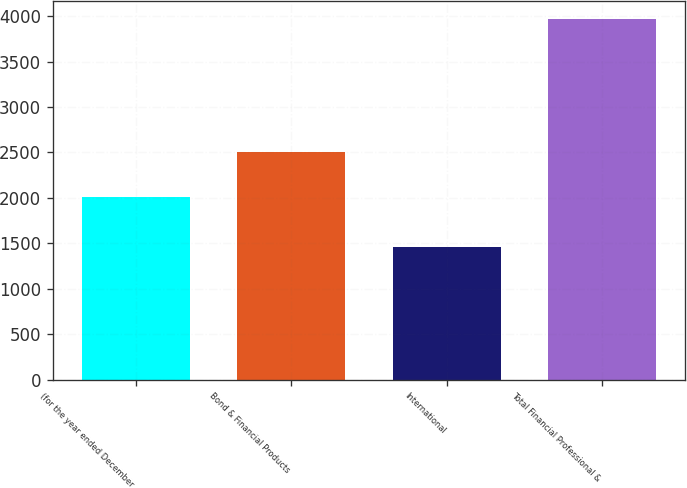Convert chart. <chart><loc_0><loc_0><loc_500><loc_500><bar_chart><fcel>(for the year ended December<fcel>Bond & Financial Products<fcel>International<fcel>Total Financial Professional &<nl><fcel>2008<fcel>2507<fcel>1459<fcel>3966<nl></chart> 